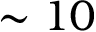Convert formula to latex. <formula><loc_0><loc_0><loc_500><loc_500>\sim 1 0</formula> 